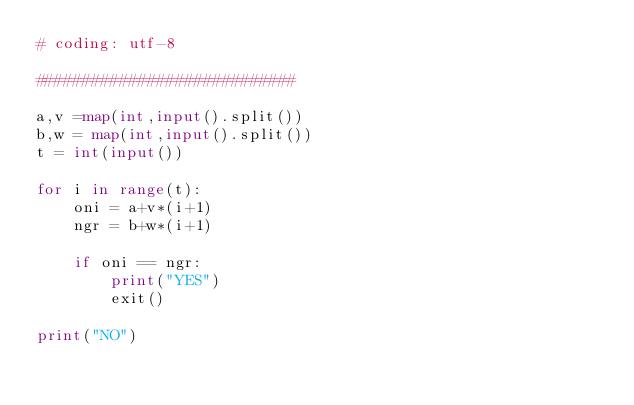<code> <loc_0><loc_0><loc_500><loc_500><_Python_># coding: utf-8

############################

a,v =map(int,input().split())
b,w = map(int,input().split())
t = int(input())

for i in range(t):
    oni = a+v*(i+1)
    ngr = b+w*(i+1)

    if oni == ngr:
        print("YES")
        exit()

print("NO")</code> 